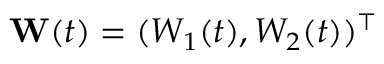Convert formula to latex. <formula><loc_0><loc_0><loc_500><loc_500>\mathbf W ( t ) = ( W _ { 1 } ( t ) , W _ { 2 } ( t ) ) ^ { \top }</formula> 